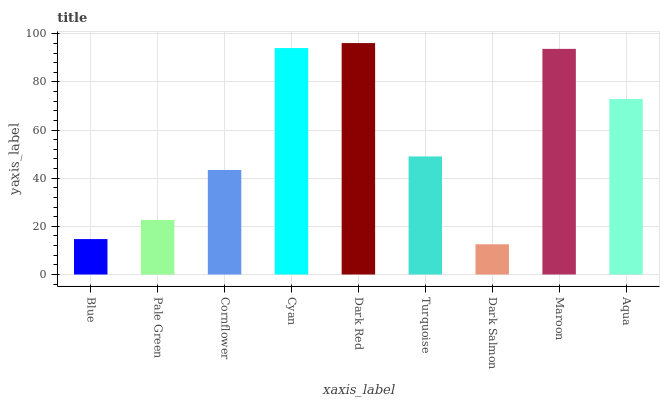Is Pale Green the minimum?
Answer yes or no. No. Is Pale Green the maximum?
Answer yes or no. No. Is Pale Green greater than Blue?
Answer yes or no. Yes. Is Blue less than Pale Green?
Answer yes or no. Yes. Is Blue greater than Pale Green?
Answer yes or no. No. Is Pale Green less than Blue?
Answer yes or no. No. Is Turquoise the high median?
Answer yes or no. Yes. Is Turquoise the low median?
Answer yes or no. Yes. Is Maroon the high median?
Answer yes or no. No. Is Maroon the low median?
Answer yes or no. No. 